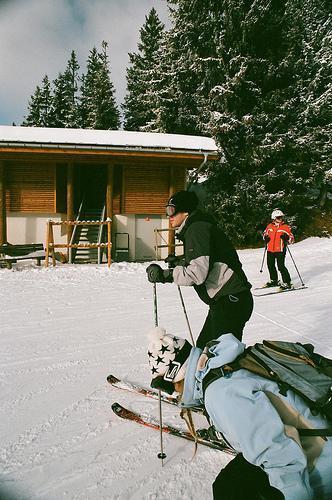How many people are wearing backpacks?
Give a very brief answer. 1. 